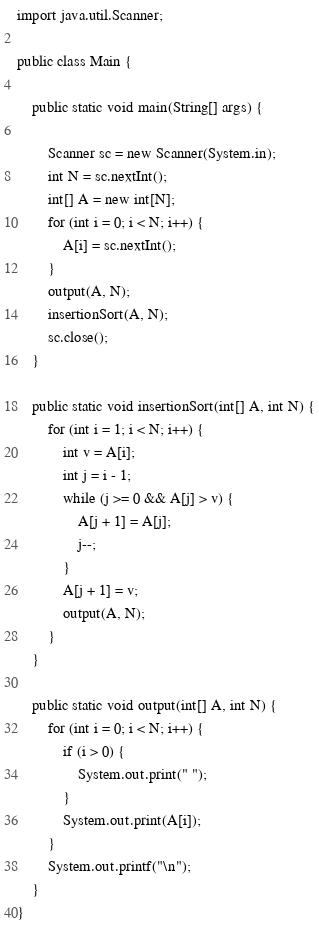Convert code to text. <code><loc_0><loc_0><loc_500><loc_500><_Java_>import java.util.Scanner;

public class Main {

	public static void main(String[] args) {

		Scanner sc = new Scanner(System.in);
		int N = sc.nextInt();
		int[] A = new int[N];
		for (int i = 0; i < N; i++) {
			A[i] = sc.nextInt();
		}
		output(A, N);
		insertionSort(A, N);
		sc.close();
	}

	public static void insertionSort(int[] A, int N) {
		for (int i = 1; i < N; i++) {
			int v = A[i];
			int j = i - 1;
			while (j >= 0 && A[j] > v) {
				A[j + 1] = A[j];
				j--;
			}
			A[j + 1] = v;
			output(A, N);
		}
	}

	public static void output(int[] A, int N) {
		for (int i = 0; i < N; i++) {
			if (i > 0) {
				System.out.print(" ");
			}
			System.out.print(A[i]);
		}
		System.out.printf("\n");
	}
}

</code> 